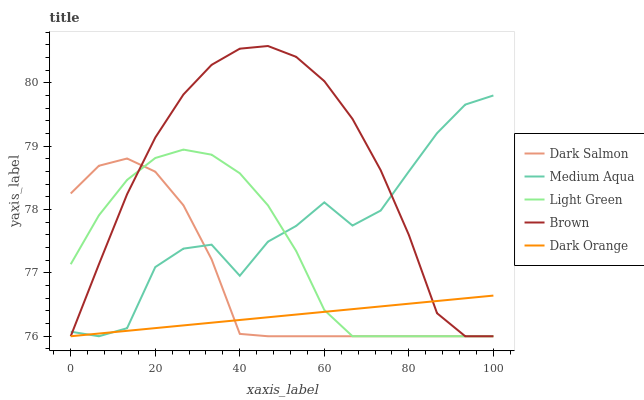Does Dark Orange have the minimum area under the curve?
Answer yes or no. Yes. Does Brown have the maximum area under the curve?
Answer yes or no. Yes. Does Medium Aqua have the minimum area under the curve?
Answer yes or no. No. Does Medium Aqua have the maximum area under the curve?
Answer yes or no. No. Is Dark Orange the smoothest?
Answer yes or no. Yes. Is Medium Aqua the roughest?
Answer yes or no. Yes. Is Dark Salmon the smoothest?
Answer yes or no. No. Is Dark Salmon the roughest?
Answer yes or no. No. Does Medium Aqua have the highest value?
Answer yes or no. No. 